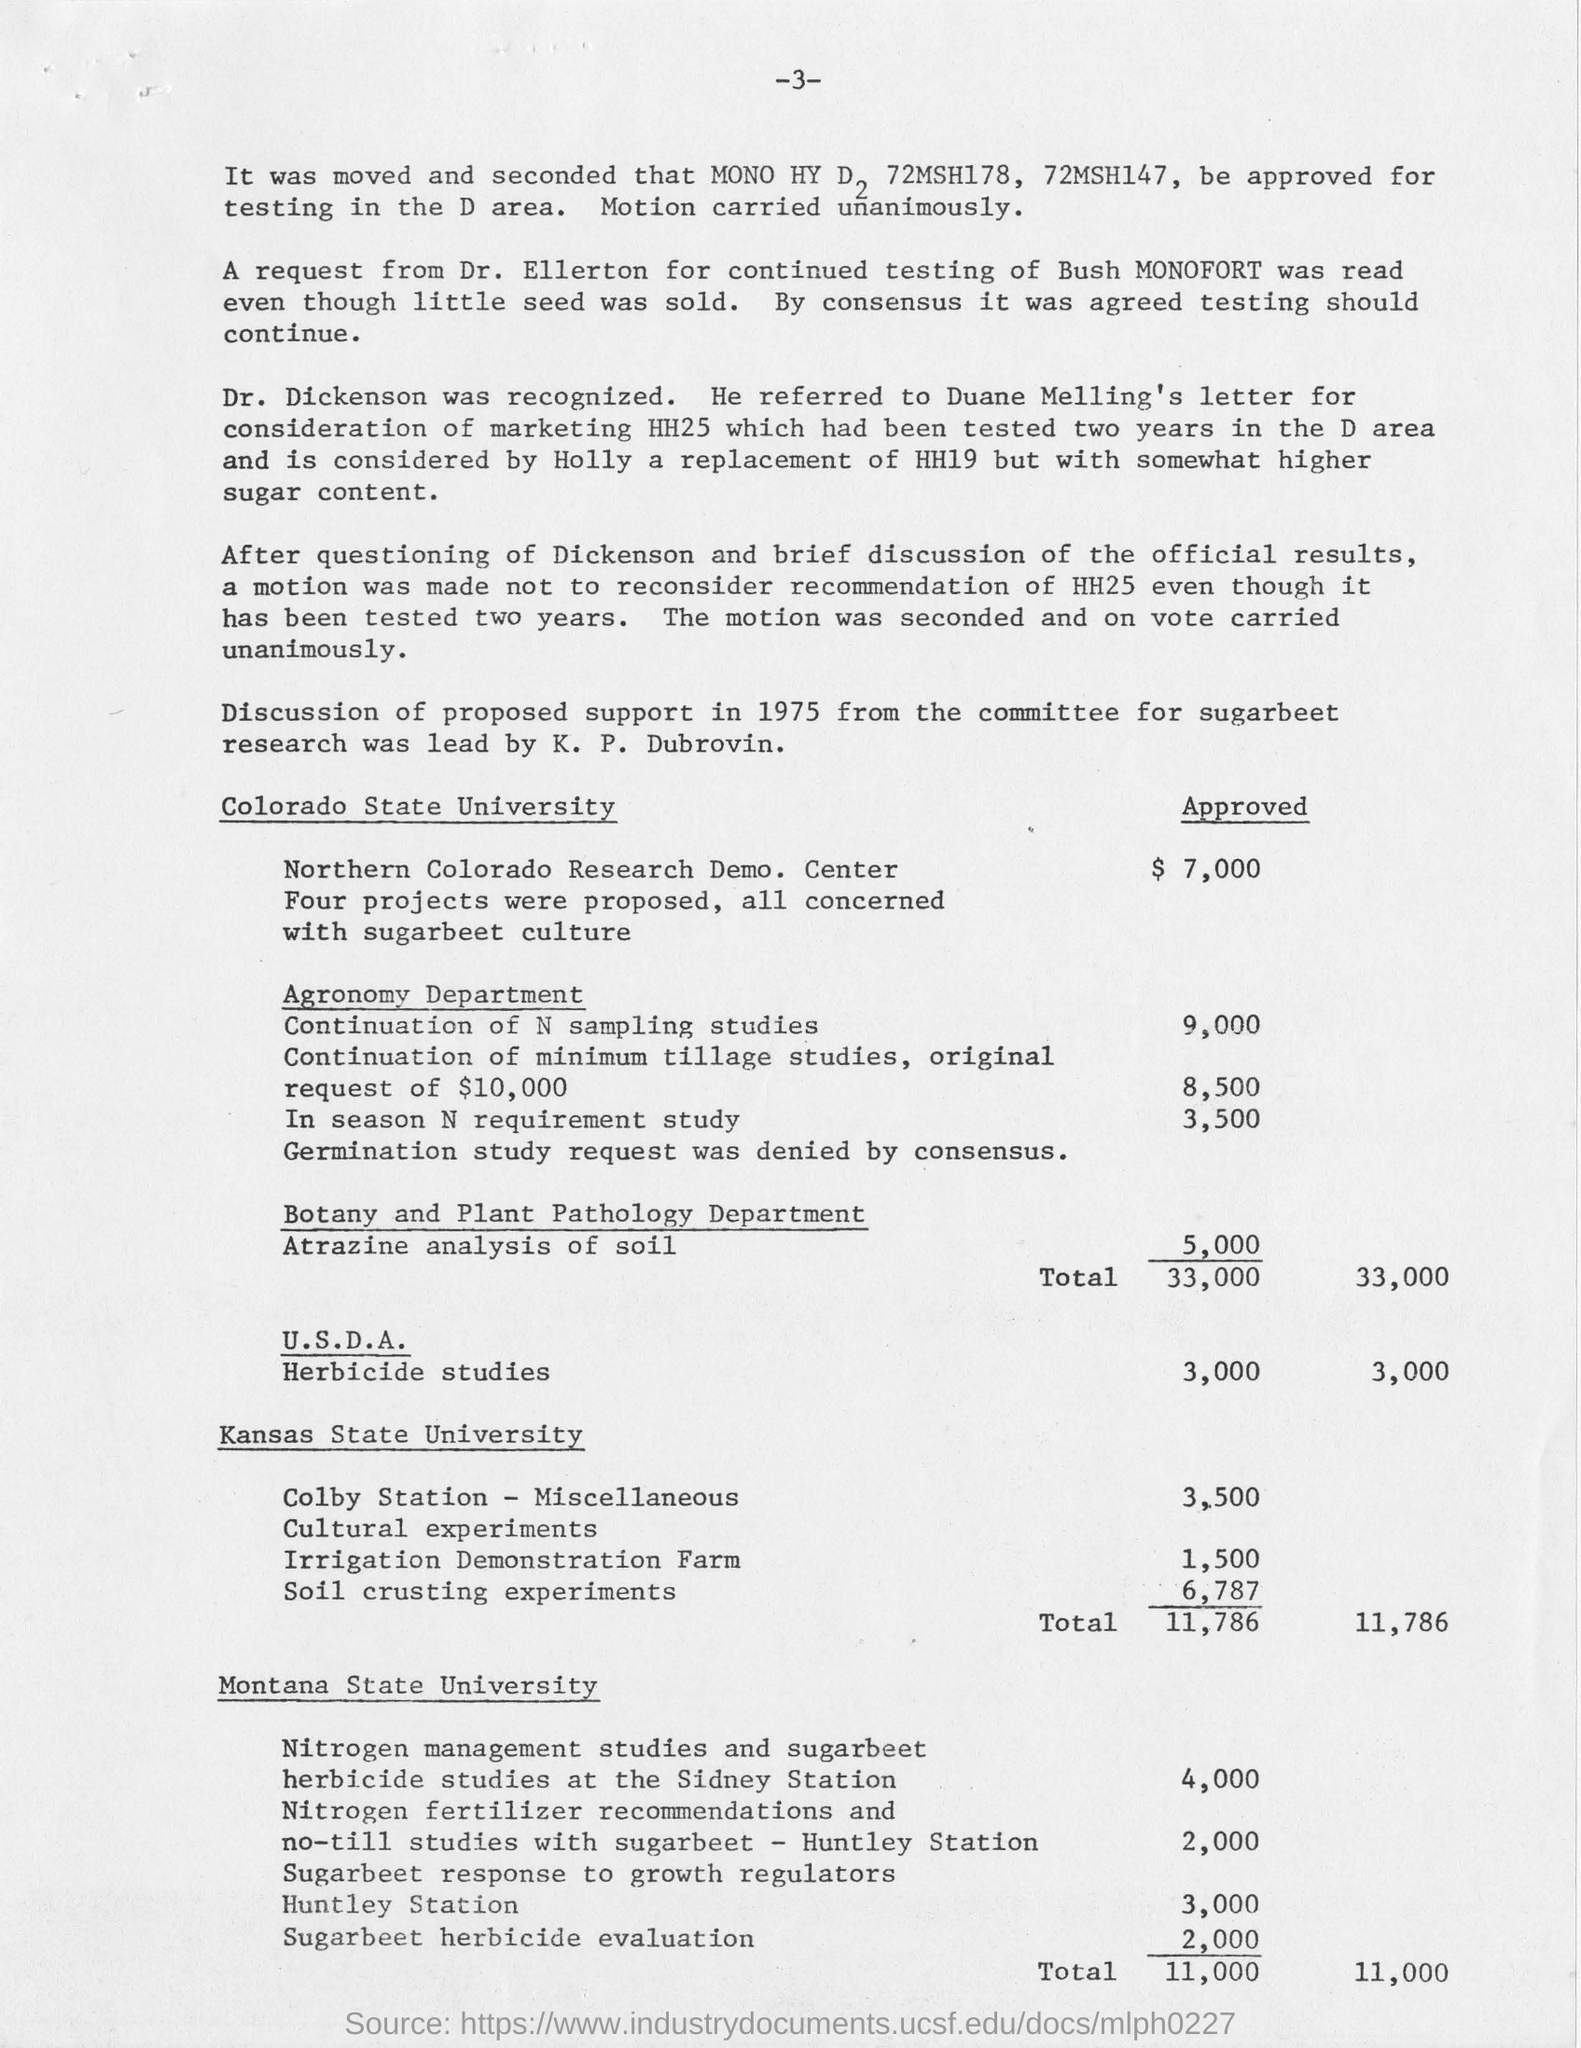What is the approved amount for Herbicide Studies under "U.S.D.A."
Provide a short and direct response. 3,000. Who leads the research?
Keep it short and to the point. K. P. Dubrovin. 